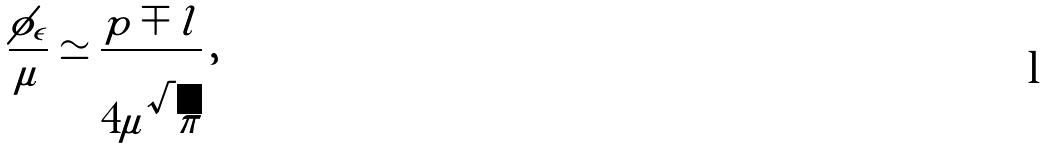Convert formula to latex. <formula><loc_0><loc_0><loc_500><loc_500>\frac { \phi _ { \epsilon } } { \mu } \simeq \frac { p \mp l } { 4 \mu \sqrt { \pi } } \, ,</formula> 